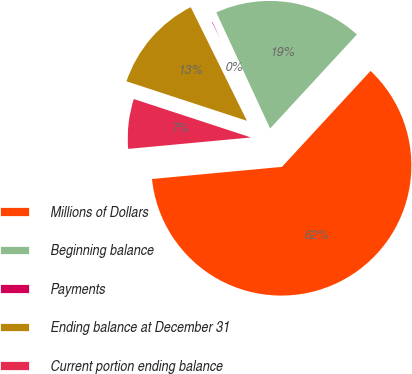<chart> <loc_0><loc_0><loc_500><loc_500><pie_chart><fcel>Millions of Dollars<fcel>Beginning balance<fcel>Payments<fcel>Ending balance at December 31<fcel>Current portion ending balance<nl><fcel>61.65%<fcel>18.77%<fcel>0.4%<fcel>12.65%<fcel>6.52%<nl></chart> 